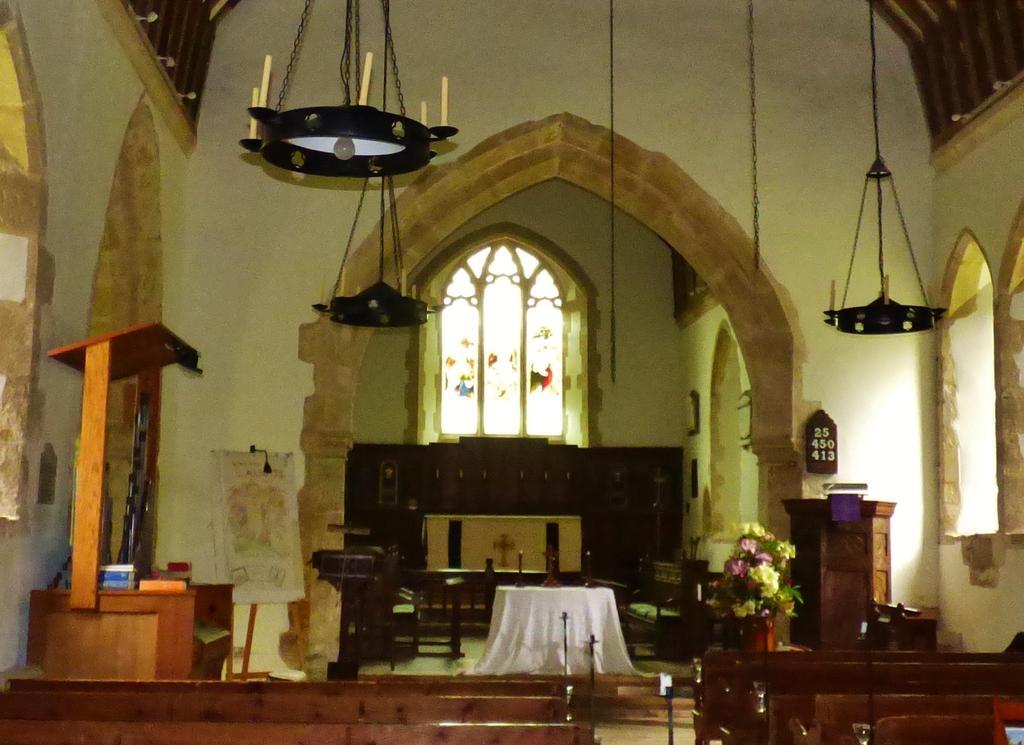How would you summarize this image in a sentence or two? This picture might be taken in a church, in this image at the bottom there are some benches and in the center there are some tables, flower pots, and some objects. And in the background there is a window, tables, and wall. And at the top of the image there are some candles, chains and some objects. On the right side and left side there is wall and there might be windows, at the bottom there is floor. 